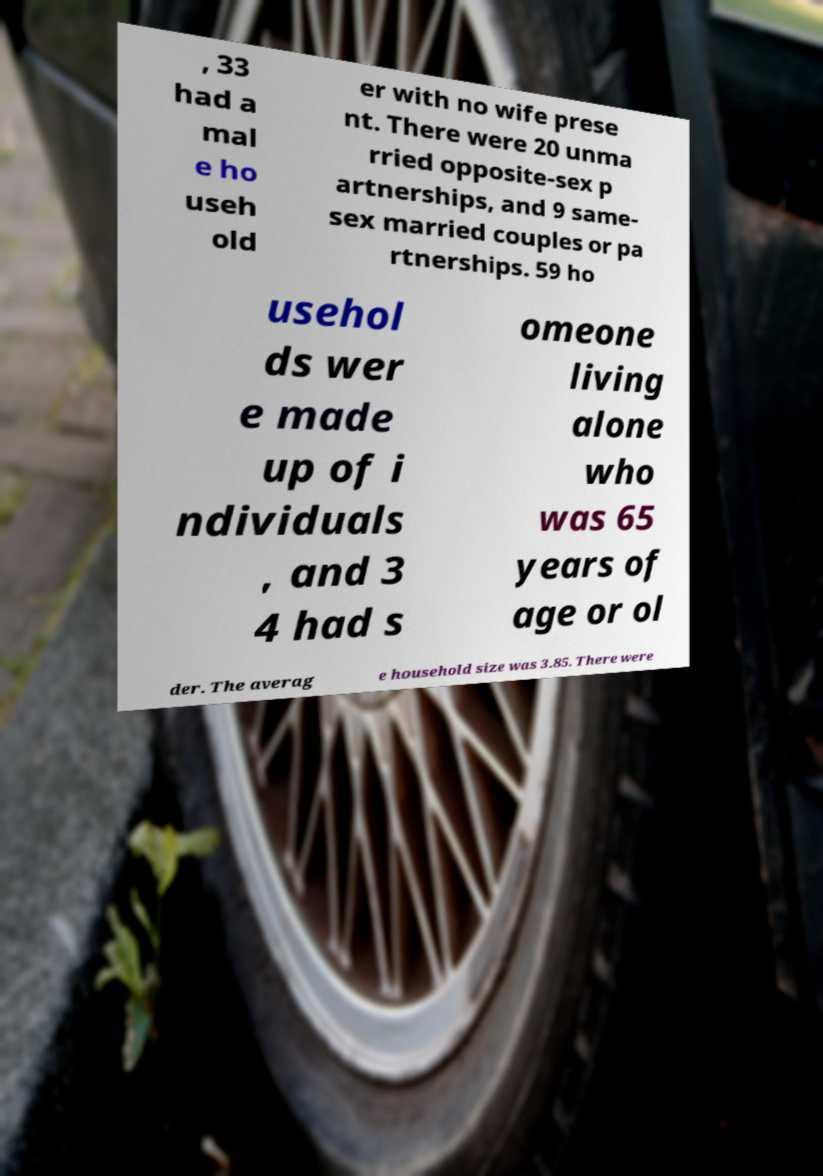I need the written content from this picture converted into text. Can you do that? , 33 had a mal e ho useh old er with no wife prese nt. There were 20 unma rried opposite-sex p artnerships, and 9 same- sex married couples or pa rtnerships. 59 ho usehol ds wer e made up of i ndividuals , and 3 4 had s omeone living alone who was 65 years of age or ol der. The averag e household size was 3.85. There were 